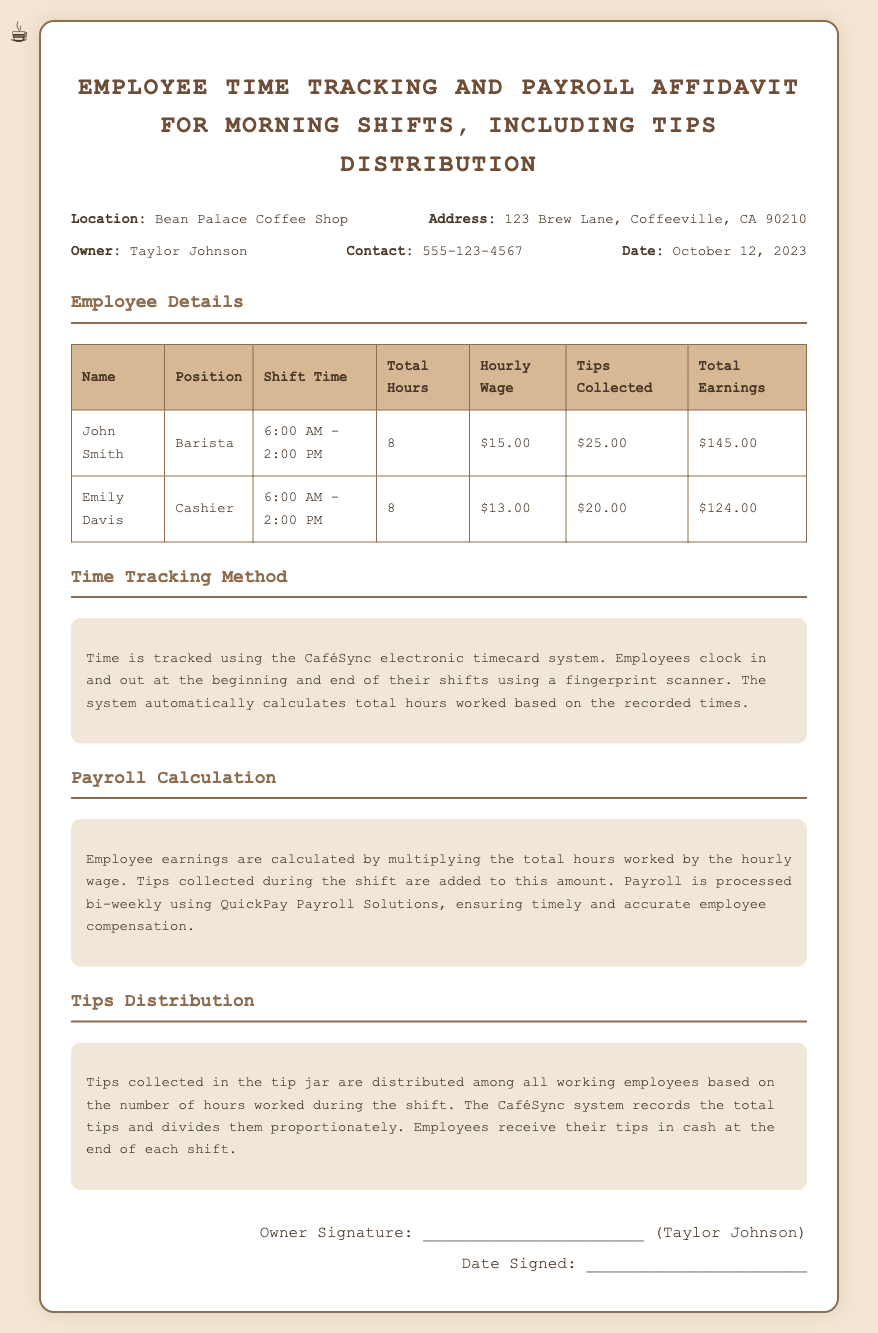What is the location of the coffee shop? The location is stated in the document as Bean Palace Coffee Shop.
Answer: Bean Palace Coffee Shop Who is the owner of the coffee shop? The document specifies that Taylor Johnson is the owner of the coffee shop.
Answer: Taylor Johnson What is the date of the affidavit? The date mentioned in the document is October 12, 2023.
Answer: October 12, 2023 What is John Smith's position? The document lists John Smith's position as Barista.
Answer: Barista How many total hours did Emily Davis work? The total hours for Emily Davis are provided as 8 in the document.
Answer: 8 How are tips distributed among employees? The document explains that tips are distributed based on the number of hours worked during the shift.
Answer: Based on hours worked What system is used for time tracking? The document states that the CaféSync electronic timecard system is used for time tracking.
Answer: CaféSync electronic timecard system How often is payroll processed? The document mentions that payroll is processed bi-weekly.
Answer: Bi-weekly What is Emily Davis’s total earnings? The total earnings for Emily Davis are mentioned as $124.00 in the document.
Answer: $124.00 